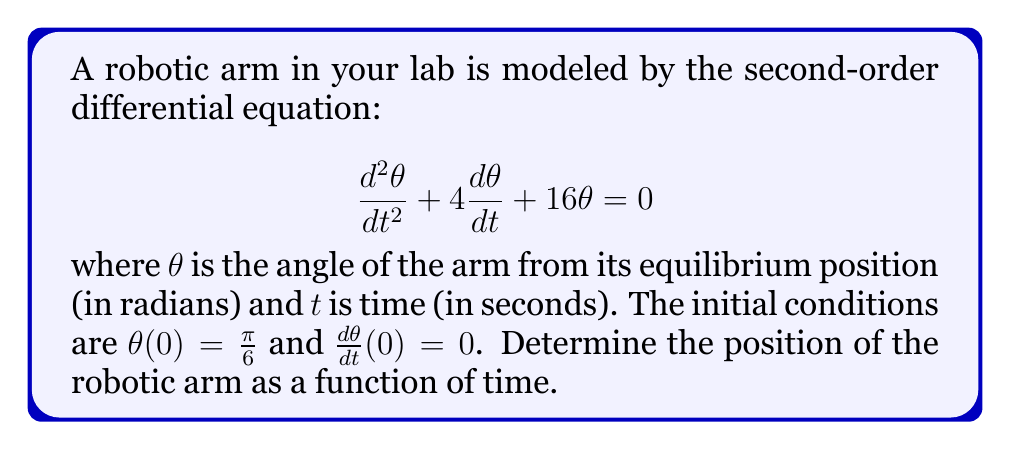Help me with this question. To solve this second-order linear differential equation, we follow these steps:

1) The characteristic equation for this differential equation is:
   $$r^2 + 4r + 16 = 0$$

2) Solving this quadratic equation:
   $$r = \frac{-4 \pm \sqrt{4^2 - 4(1)(16)}}{2(1)} = \frac{-4 \pm \sqrt{-48}}{2} = -2 \pm 2i\sqrt{3}$$

3) The general solution is therefore:
   $$\theta(t) = e^{-2t}(A\cos(2\sqrt{3}t) + B\sin(2\sqrt{3}t))$$
   where $A$ and $B$ are constants to be determined from the initial conditions.

4) Using the first initial condition, $\theta(0) = \frac{\pi}{6}$:
   $$\frac{\pi}{6} = A$$

5) For the second initial condition, we need $\frac{d\theta}{dt}$:
   $$\frac{d\theta}{dt} = -2e^{-2t}(A\cos(2\sqrt{3}t) + B\sin(2\sqrt{3}t)) + e^{-2t}(-2\sqrt{3}A\sin(2\sqrt{3}t) + 2\sqrt{3}B\cos(2\sqrt{3}t))$$

6) Applying the second initial condition, $\frac{d\theta}{dt}(0) = 0$:
   $$0 = -2A + 2\sqrt{3}B$$
   $$B = \frac{A}{\sqrt{3}} = \frac{\pi}{6\sqrt{3}}$$

7) Substituting these values back into the general solution:
   $$\theta(t) = e^{-2t}(\frac{\pi}{6}\cos(2\sqrt{3}t) + \frac{\pi}{6\sqrt{3}}\sin(2\sqrt{3}t))$$
Answer: $$\theta(t) = \frac{\pi}{6}e^{-2t}(\cos(2\sqrt{3}t) + \frac{1}{\sqrt{3}}\sin(2\sqrt{3}t))$$ 